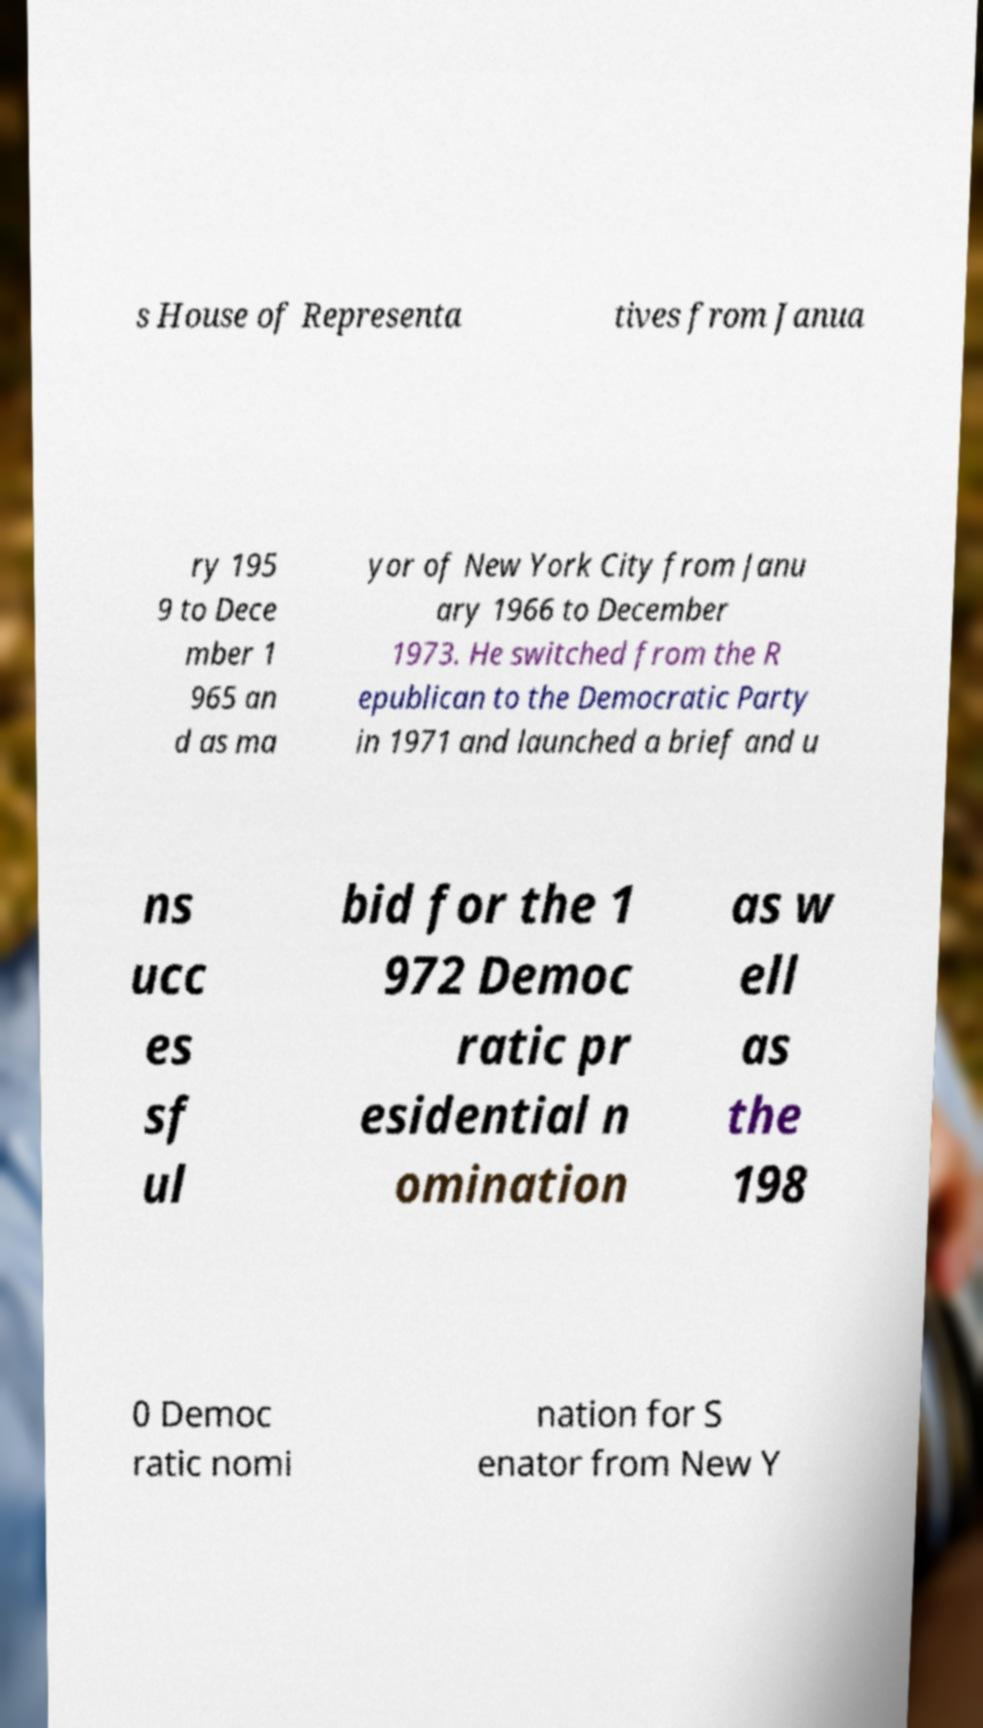I need the written content from this picture converted into text. Can you do that? s House of Representa tives from Janua ry 195 9 to Dece mber 1 965 an d as ma yor of New York City from Janu ary 1966 to December 1973. He switched from the R epublican to the Democratic Party in 1971 and launched a brief and u ns ucc es sf ul bid for the 1 972 Democ ratic pr esidential n omination as w ell as the 198 0 Democ ratic nomi nation for S enator from New Y 